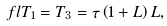<formula> <loc_0><loc_0><loc_500><loc_500>\ f l T _ { 1 } = T _ { 3 } = \tau \left ( 1 + L \right ) L ,</formula> 